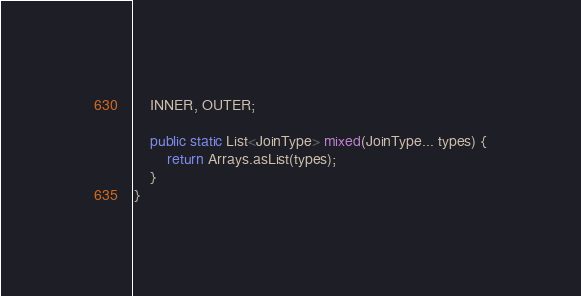<code> <loc_0><loc_0><loc_500><loc_500><_Java_>    INNER, OUTER;

    public static List<JoinType> mixed(JoinType... types) {
        return Arrays.asList(types);
    }
}</code> 